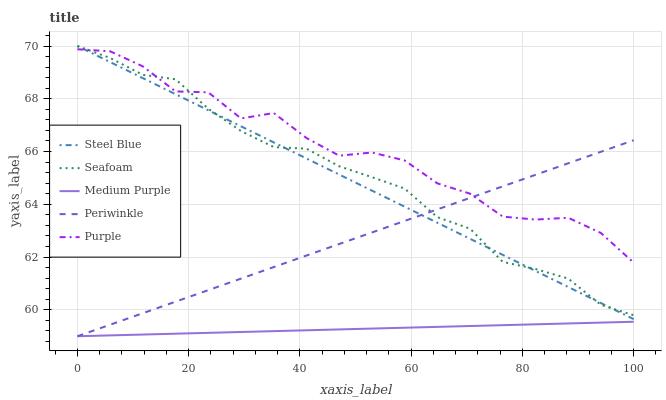Does Medium Purple have the minimum area under the curve?
Answer yes or no. Yes. Does Purple have the maximum area under the curve?
Answer yes or no. Yes. Does Periwinkle have the minimum area under the curve?
Answer yes or no. No. Does Periwinkle have the maximum area under the curve?
Answer yes or no. No. Is Medium Purple the smoothest?
Answer yes or no. Yes. Is Purple the roughest?
Answer yes or no. Yes. Is Periwinkle the smoothest?
Answer yes or no. No. Is Periwinkle the roughest?
Answer yes or no. No. Does Medium Purple have the lowest value?
Answer yes or no. Yes. Does Purple have the lowest value?
Answer yes or no. No. Does Seafoam have the highest value?
Answer yes or no. Yes. Does Purple have the highest value?
Answer yes or no. No. Is Medium Purple less than Seafoam?
Answer yes or no. Yes. Is Seafoam greater than Medium Purple?
Answer yes or no. Yes. Does Periwinkle intersect Seafoam?
Answer yes or no. Yes. Is Periwinkle less than Seafoam?
Answer yes or no. No. Is Periwinkle greater than Seafoam?
Answer yes or no. No. Does Medium Purple intersect Seafoam?
Answer yes or no. No. 